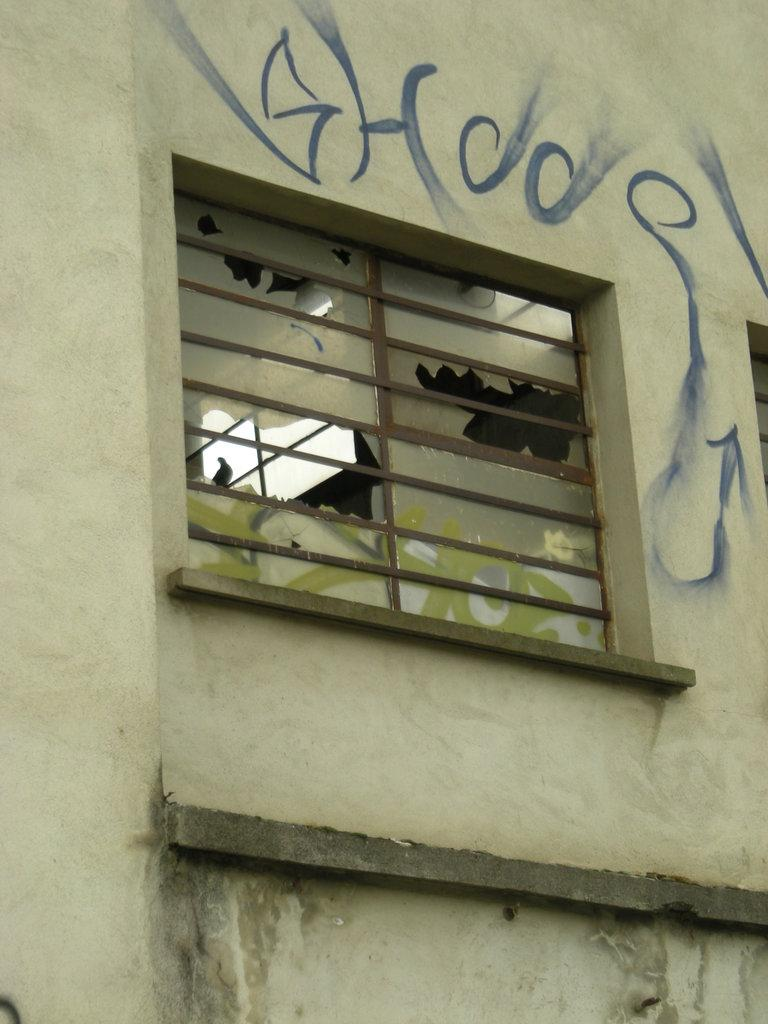What type of structure can be seen in the image? There is a wall in the image. Are there any openings in the wall? Yes, there is a window in the wall. What can be found on the wall besides the window? There is text visible on the wall. What type of cannon is depicted on the wall in the image? There is no cannon present on the wall in the image. What emotion does the wall express in the image? The wall is an inanimate object and does not express emotions like fear. 